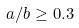Convert formula to latex. <formula><loc_0><loc_0><loc_500><loc_500>a / b \geq 0 . 3</formula> 